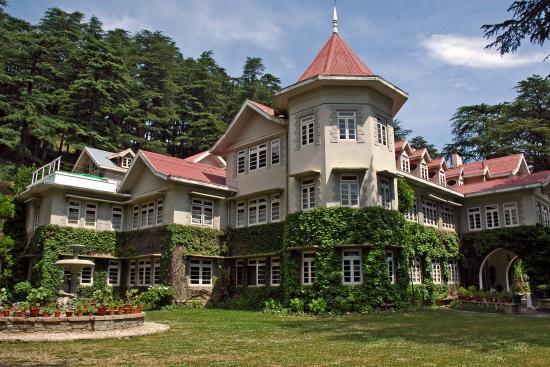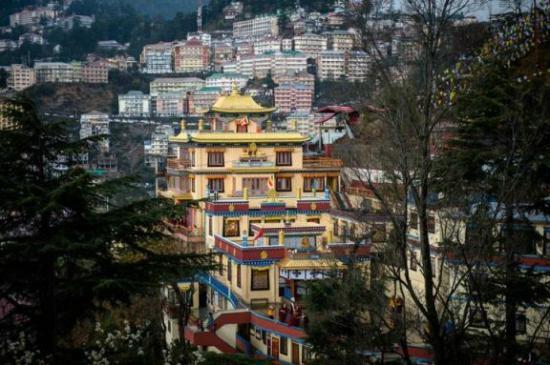The first image is the image on the left, the second image is the image on the right. Given the left and right images, does the statement "The roof is pink on the structure in the image on the left." hold true? Answer yes or no. Yes. 